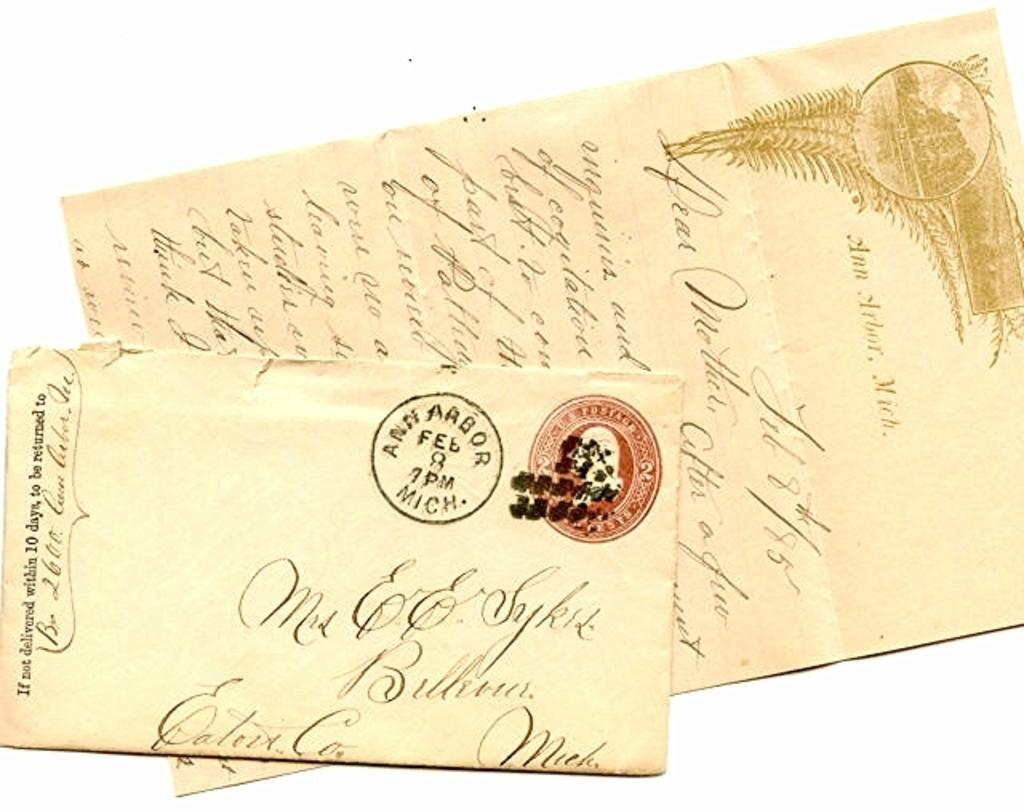What can be seen in the image? There are two letters in the image. Can you describe the appearance of the letters? Unfortunately, the appearance of the letters cannot be described without more information about their style, size, or color. What might the letters represent or convey? The meaning or purpose of the letters cannot be determined without additional context or information. What type of organization is depicted in the image? There is no organization depicted in the image; it only contains two letters. How does the haircut of the person in the image look? There is no person present in the image, so it is not possible to describe their haircut. 